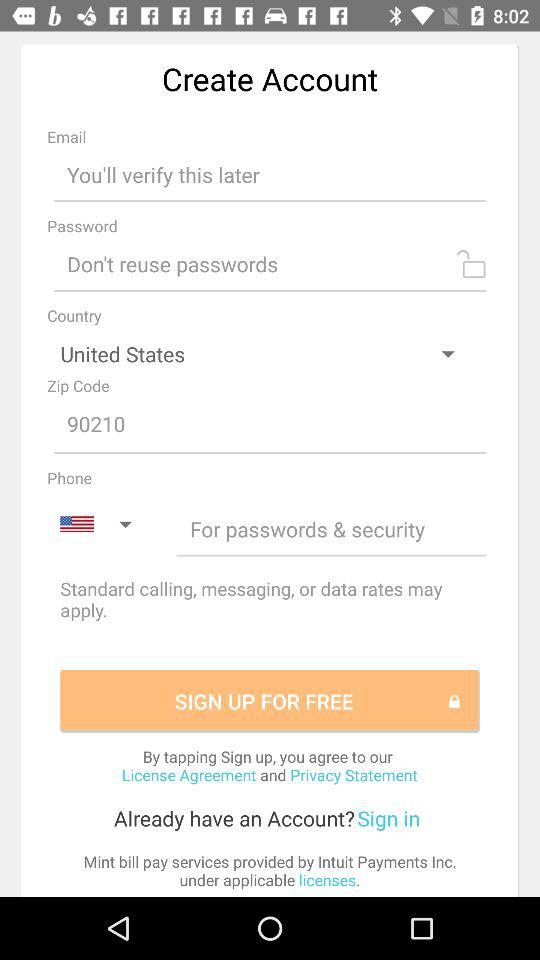What is the zip code? The zip code is 90210. 